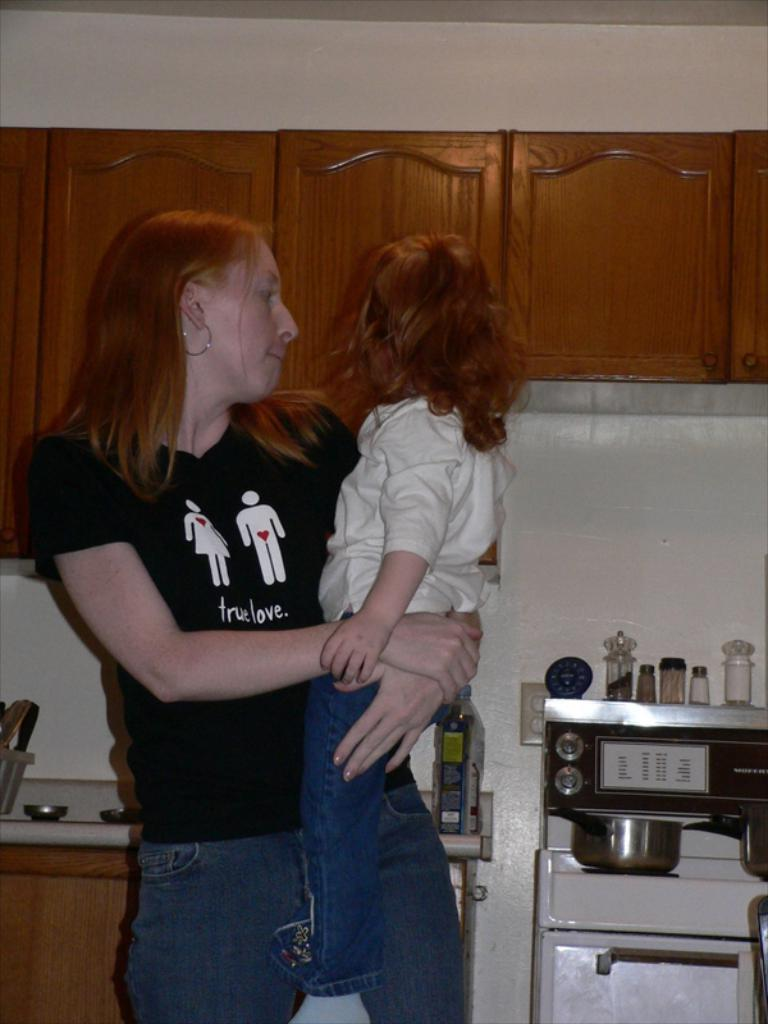<image>
Share a concise interpretation of the image provided. The person that is holding the child has a t-shirt that reads "true love" on it. 